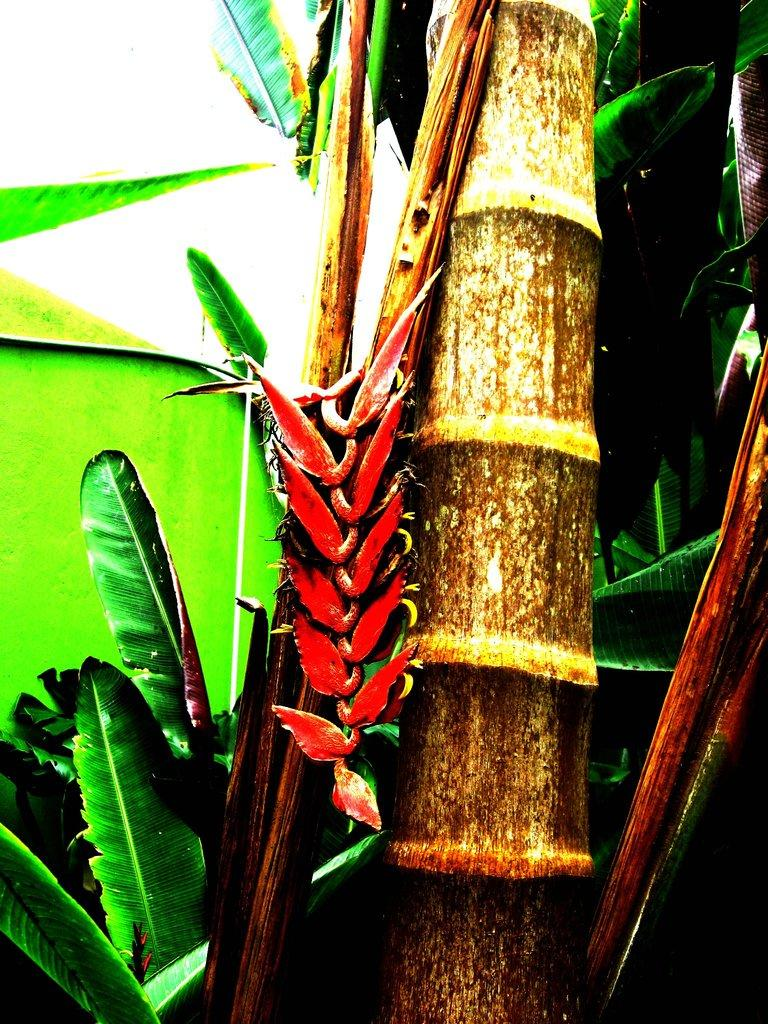What type of plant is featured in the image? There are banana flowers in the image. What other parts of the plant can be seen in the image? There are leaves and a stem in the image. What color is the crayon used to draw the ant in the image? There is no crayon or ant present in the image; it features banana flowers, leaves, and a stem. 